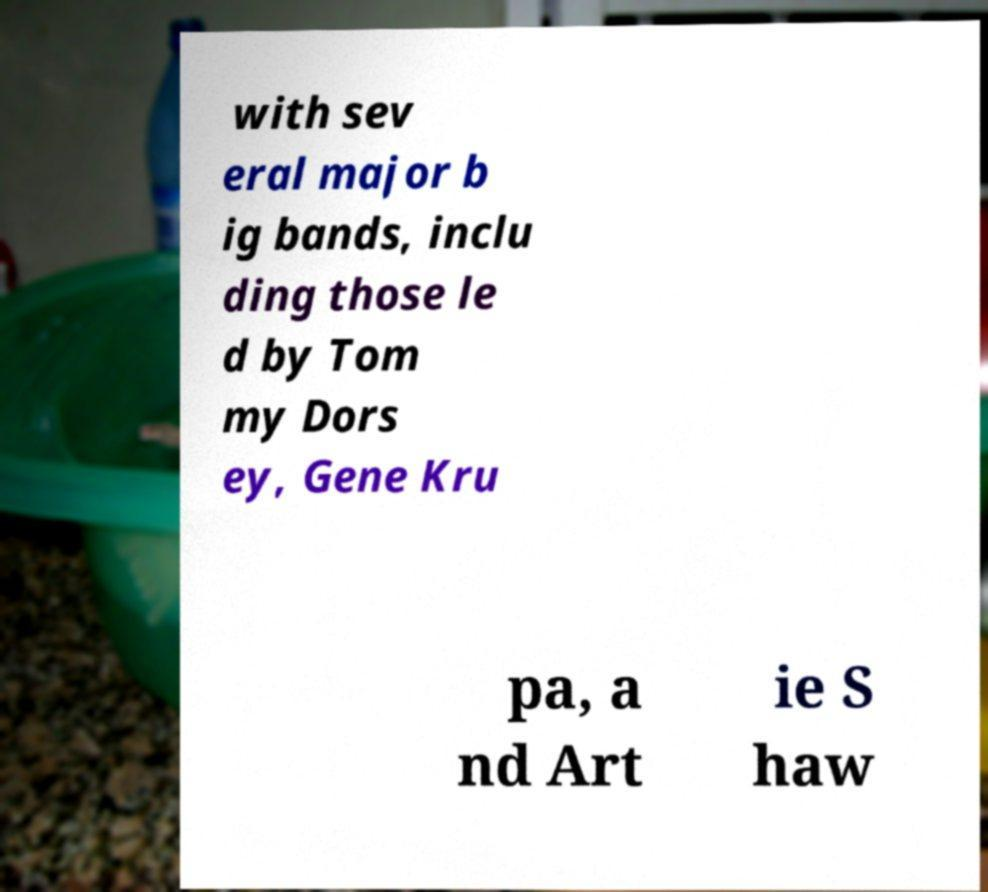There's text embedded in this image that I need extracted. Can you transcribe it verbatim? with sev eral major b ig bands, inclu ding those le d by Tom my Dors ey, Gene Kru pa, a nd Art ie S haw 